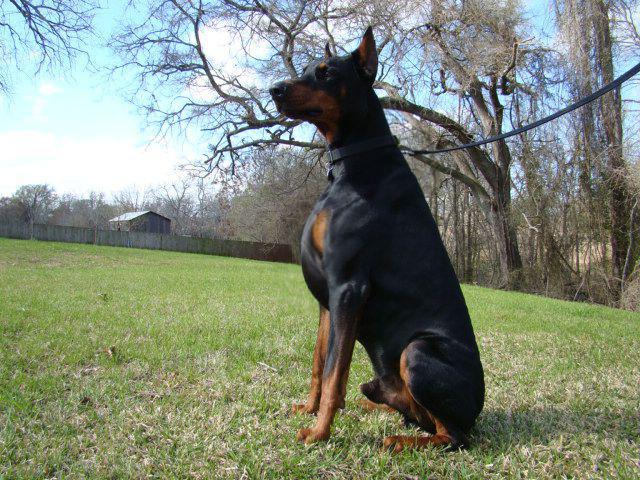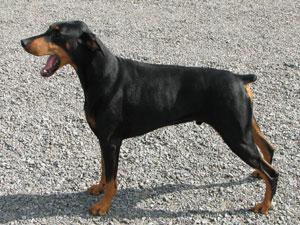The first image is the image on the left, the second image is the image on the right. Evaluate the accuracy of this statement regarding the images: "There is a young puppy in one image.". Is it true? Answer yes or no. No. The first image is the image on the left, the second image is the image on the right. Considering the images on both sides, is "One of the dogs has floppy ears." valid? Answer yes or no. No. 